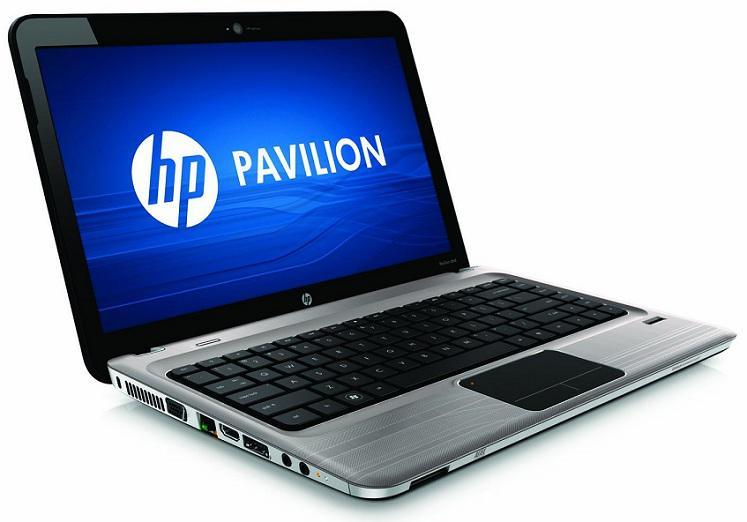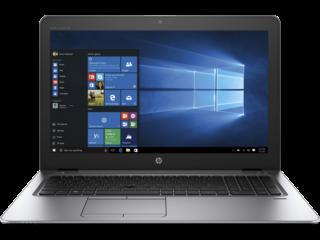The first image is the image on the left, the second image is the image on the right. Considering the images on both sides, is "At least one laptop is pictured against a black background." valid? Answer yes or no. Yes. 